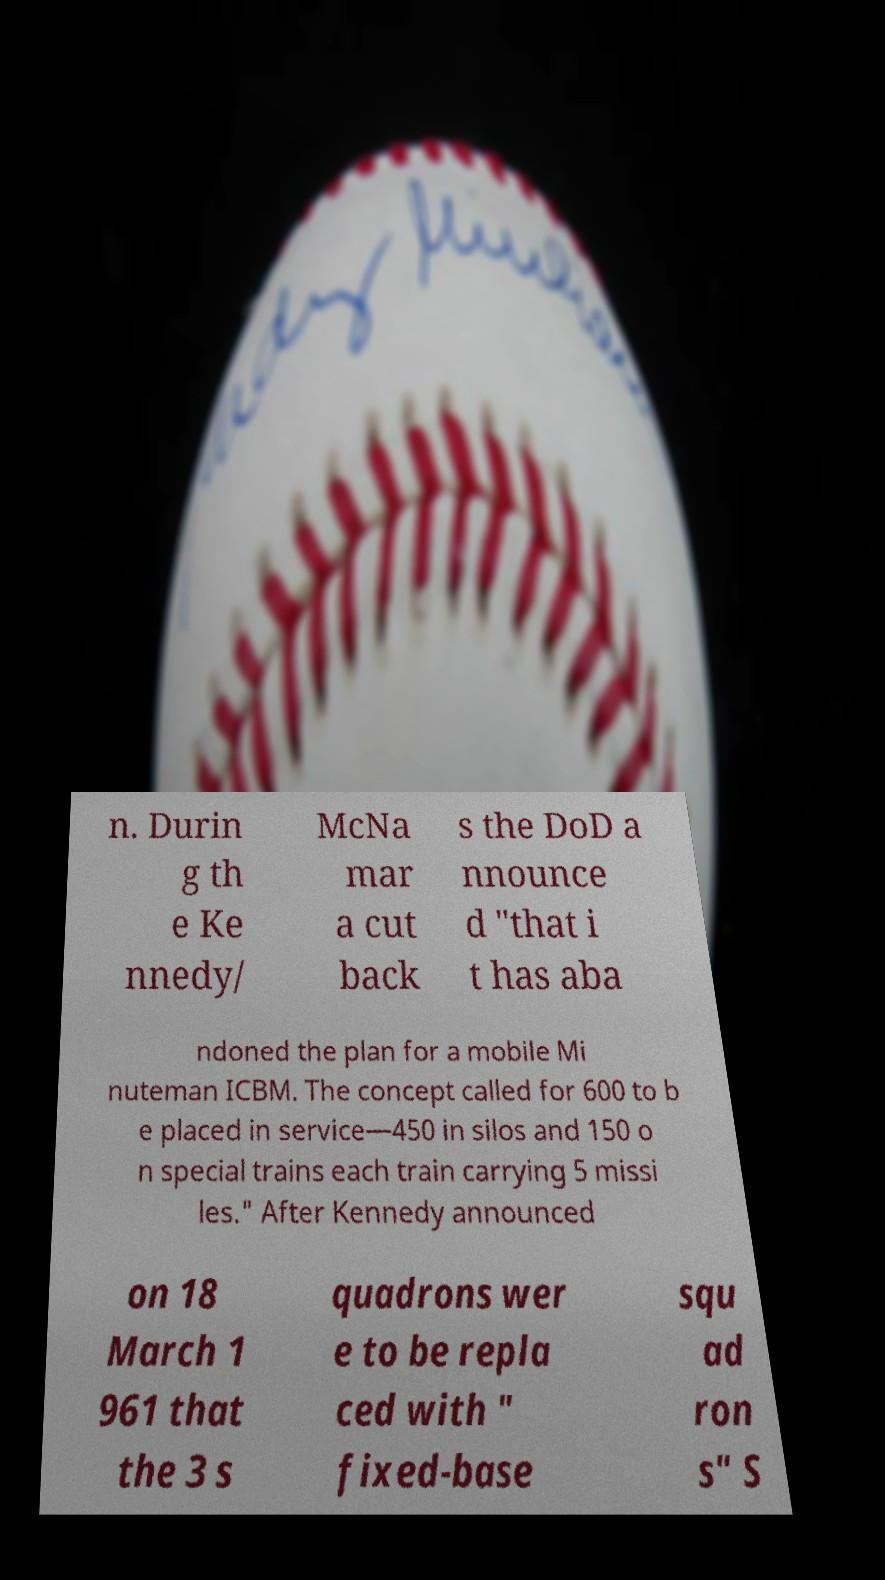Can you accurately transcribe the text from the provided image for me? n. Durin g th e Ke nnedy/ McNa mar a cut back s the DoD a nnounce d "that i t has aba ndoned the plan for a mobile Mi nuteman ICBM. The concept called for 600 to b e placed in service—450 in silos and 150 o n special trains each train carrying 5 missi les." After Kennedy announced on 18 March 1 961 that the 3 s quadrons wer e to be repla ced with " fixed-base squ ad ron s" S 